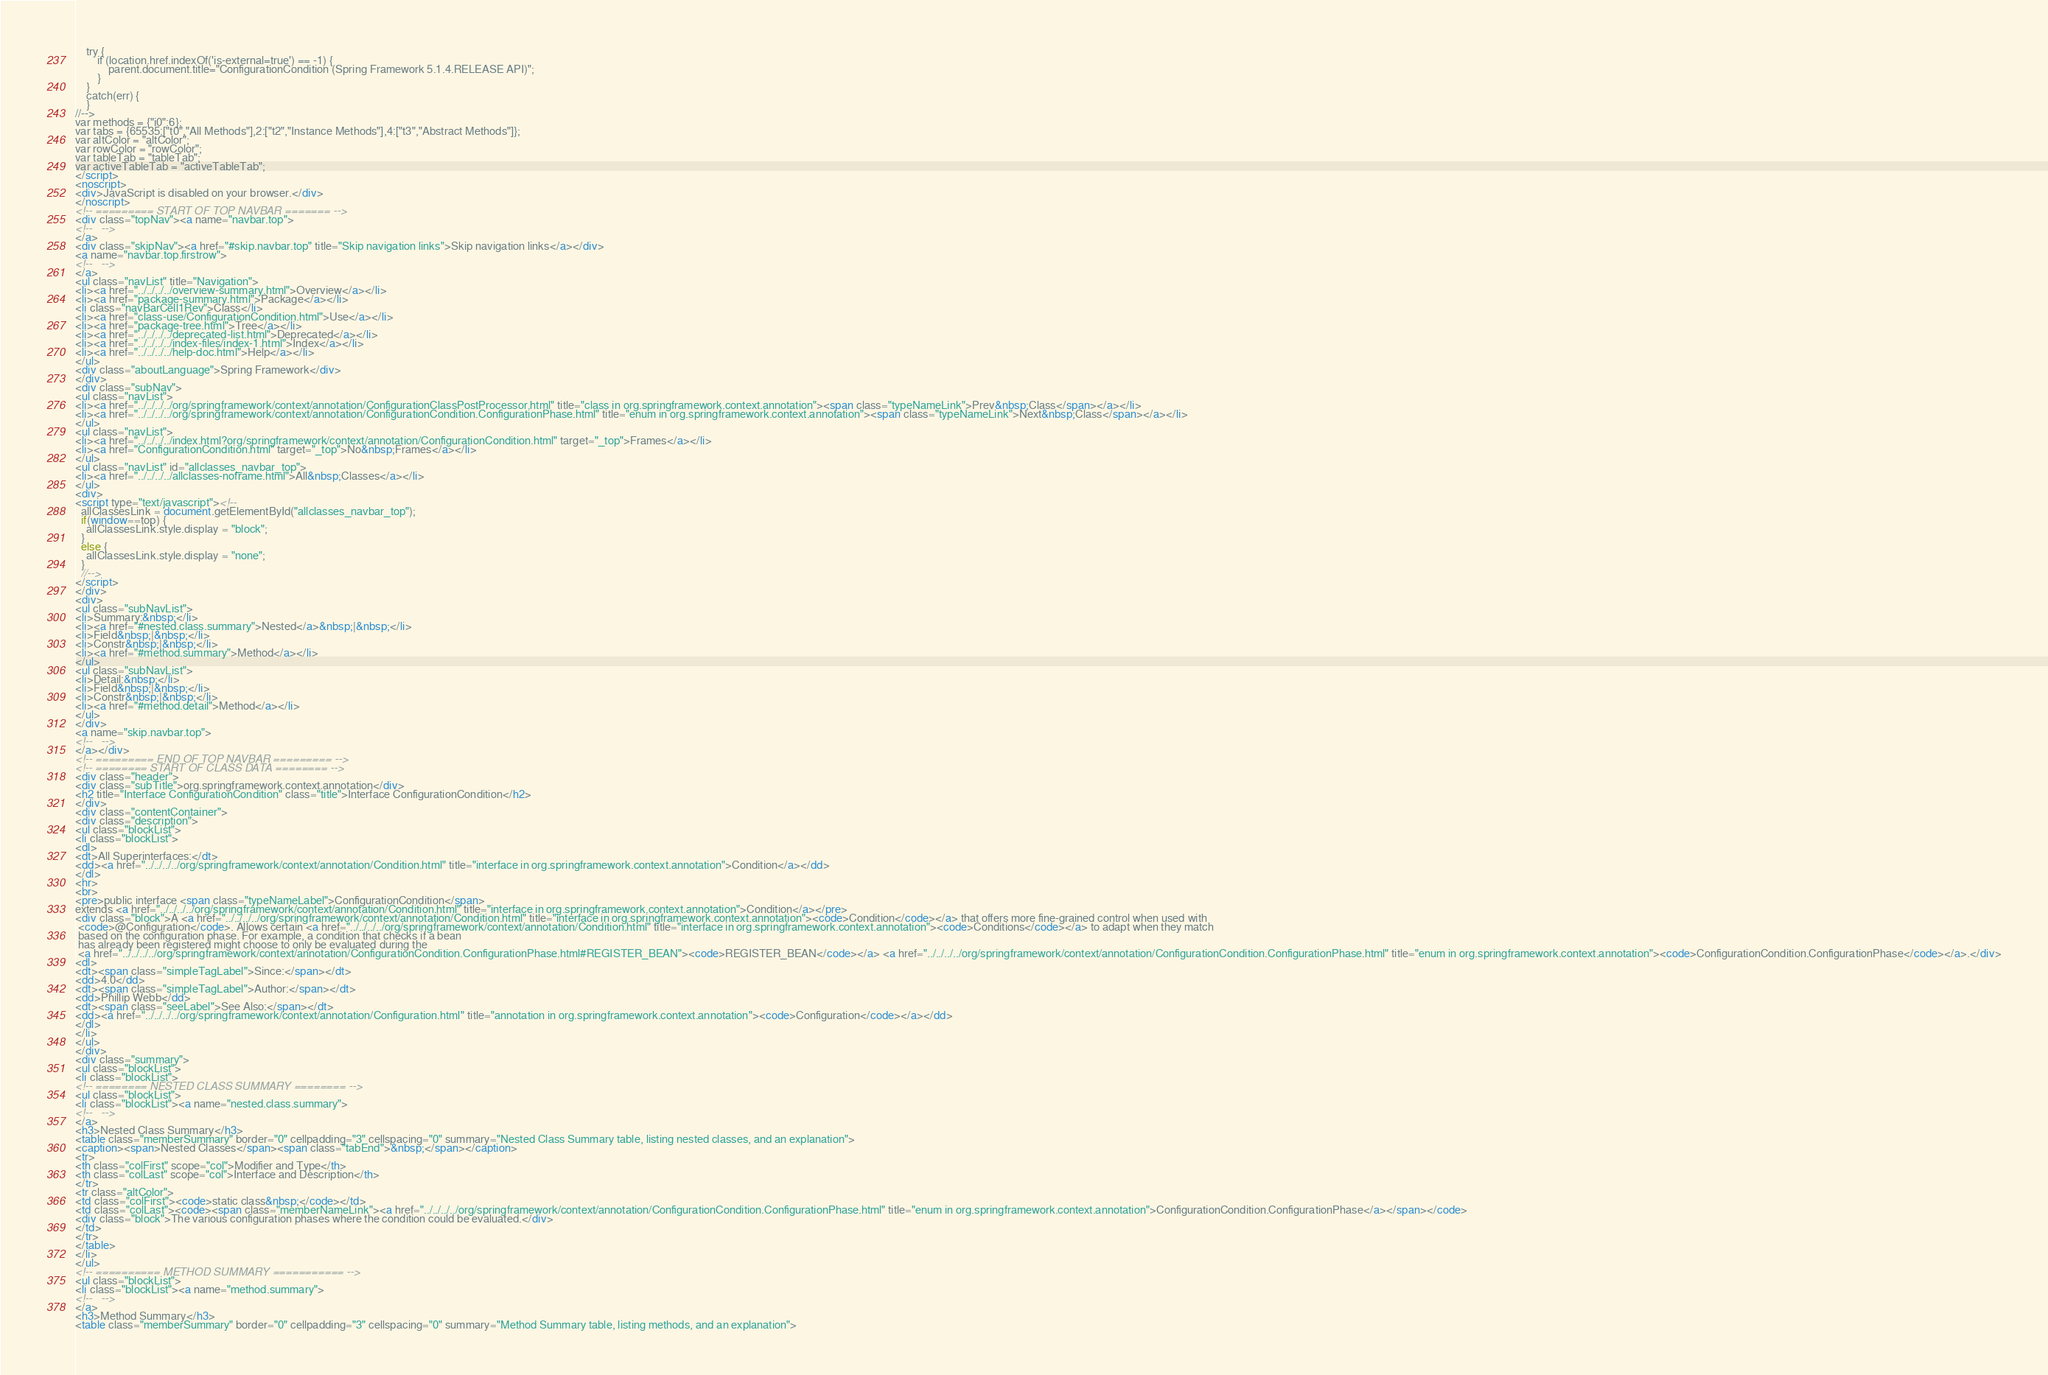Convert code to text. <code><loc_0><loc_0><loc_500><loc_500><_HTML_>    try {
        if (location.href.indexOf('is-external=true') == -1) {
            parent.document.title="ConfigurationCondition (Spring Framework 5.1.4.RELEASE API)";
        }
    }
    catch(err) {
    }
//-->
var methods = {"i0":6};
var tabs = {65535:["t0","All Methods"],2:["t2","Instance Methods"],4:["t3","Abstract Methods"]};
var altColor = "altColor";
var rowColor = "rowColor";
var tableTab = "tableTab";
var activeTableTab = "activeTableTab";
</script>
<noscript>
<div>JavaScript is disabled on your browser.</div>
</noscript>
<!-- ========= START OF TOP NAVBAR ======= -->
<div class="topNav"><a name="navbar.top">
<!--   -->
</a>
<div class="skipNav"><a href="#skip.navbar.top" title="Skip navigation links">Skip navigation links</a></div>
<a name="navbar.top.firstrow">
<!--   -->
</a>
<ul class="navList" title="Navigation">
<li><a href="../../../../overview-summary.html">Overview</a></li>
<li><a href="package-summary.html">Package</a></li>
<li class="navBarCell1Rev">Class</li>
<li><a href="class-use/ConfigurationCondition.html">Use</a></li>
<li><a href="package-tree.html">Tree</a></li>
<li><a href="../../../../deprecated-list.html">Deprecated</a></li>
<li><a href="../../../../index-files/index-1.html">Index</a></li>
<li><a href="../../../../help-doc.html">Help</a></li>
</ul>
<div class="aboutLanguage">Spring Framework</div>
</div>
<div class="subNav">
<ul class="navList">
<li><a href="../../../../org/springframework/context/annotation/ConfigurationClassPostProcessor.html" title="class in org.springframework.context.annotation"><span class="typeNameLink">Prev&nbsp;Class</span></a></li>
<li><a href="../../../../org/springframework/context/annotation/ConfigurationCondition.ConfigurationPhase.html" title="enum in org.springframework.context.annotation"><span class="typeNameLink">Next&nbsp;Class</span></a></li>
</ul>
<ul class="navList">
<li><a href="../../../../index.html?org/springframework/context/annotation/ConfigurationCondition.html" target="_top">Frames</a></li>
<li><a href="ConfigurationCondition.html" target="_top">No&nbsp;Frames</a></li>
</ul>
<ul class="navList" id="allclasses_navbar_top">
<li><a href="../../../../allclasses-noframe.html">All&nbsp;Classes</a></li>
</ul>
<div>
<script type="text/javascript"><!--
  allClassesLink = document.getElementById("allclasses_navbar_top");
  if(window==top) {
    allClassesLink.style.display = "block";
  }
  else {
    allClassesLink.style.display = "none";
  }
  //-->
</script>
</div>
<div>
<ul class="subNavList">
<li>Summary:&nbsp;</li>
<li><a href="#nested.class.summary">Nested</a>&nbsp;|&nbsp;</li>
<li>Field&nbsp;|&nbsp;</li>
<li>Constr&nbsp;|&nbsp;</li>
<li><a href="#method.summary">Method</a></li>
</ul>
<ul class="subNavList">
<li>Detail:&nbsp;</li>
<li>Field&nbsp;|&nbsp;</li>
<li>Constr&nbsp;|&nbsp;</li>
<li><a href="#method.detail">Method</a></li>
</ul>
</div>
<a name="skip.navbar.top">
<!--   -->
</a></div>
<!-- ========= END OF TOP NAVBAR ========= -->
<!-- ======== START OF CLASS DATA ======== -->
<div class="header">
<div class="subTitle">org.springframework.context.annotation</div>
<h2 title="Interface ConfigurationCondition" class="title">Interface ConfigurationCondition</h2>
</div>
<div class="contentContainer">
<div class="description">
<ul class="blockList">
<li class="blockList">
<dl>
<dt>All Superinterfaces:</dt>
<dd><a href="../../../../org/springframework/context/annotation/Condition.html" title="interface in org.springframework.context.annotation">Condition</a></dd>
</dl>
<hr>
<br>
<pre>public interface <span class="typeNameLabel">ConfigurationCondition</span>
extends <a href="../../../../org/springframework/context/annotation/Condition.html" title="interface in org.springframework.context.annotation">Condition</a></pre>
<div class="block">A <a href="../../../../org/springframework/context/annotation/Condition.html" title="interface in org.springframework.context.annotation"><code>Condition</code></a> that offers more fine-grained control when used with
 <code>@Configuration</code>. Allows certain <a href="../../../../org/springframework/context/annotation/Condition.html" title="interface in org.springframework.context.annotation"><code>Conditions</code></a> to adapt when they match
 based on the configuration phase. For example, a condition that checks if a bean
 has already been registered might choose to only be evaluated during the
 <a href="../../../../org/springframework/context/annotation/ConfigurationCondition.ConfigurationPhase.html#REGISTER_BEAN"><code>REGISTER_BEAN</code></a> <a href="../../../../org/springframework/context/annotation/ConfigurationCondition.ConfigurationPhase.html" title="enum in org.springframework.context.annotation"><code>ConfigurationCondition.ConfigurationPhase</code></a>.</div>
<dl>
<dt><span class="simpleTagLabel">Since:</span></dt>
<dd>4.0</dd>
<dt><span class="simpleTagLabel">Author:</span></dt>
<dd>Phillip Webb</dd>
<dt><span class="seeLabel">See Also:</span></dt>
<dd><a href="../../../../org/springframework/context/annotation/Configuration.html" title="annotation in org.springframework.context.annotation"><code>Configuration</code></a></dd>
</dl>
</li>
</ul>
</div>
<div class="summary">
<ul class="blockList">
<li class="blockList">
<!-- ======== NESTED CLASS SUMMARY ======== -->
<ul class="blockList">
<li class="blockList"><a name="nested.class.summary">
<!--   -->
</a>
<h3>Nested Class Summary</h3>
<table class="memberSummary" border="0" cellpadding="3" cellspacing="0" summary="Nested Class Summary table, listing nested classes, and an explanation">
<caption><span>Nested Classes</span><span class="tabEnd">&nbsp;</span></caption>
<tr>
<th class="colFirst" scope="col">Modifier and Type</th>
<th class="colLast" scope="col">Interface and Description</th>
</tr>
<tr class="altColor">
<td class="colFirst"><code>static class&nbsp;</code></td>
<td class="colLast"><code><span class="memberNameLink"><a href="../../../../org/springframework/context/annotation/ConfigurationCondition.ConfigurationPhase.html" title="enum in org.springframework.context.annotation">ConfigurationCondition.ConfigurationPhase</a></span></code>
<div class="block">The various configuration phases where the condition could be evaluated.</div>
</td>
</tr>
</table>
</li>
</ul>
<!-- ========== METHOD SUMMARY =========== -->
<ul class="blockList">
<li class="blockList"><a name="method.summary">
<!--   -->
</a>
<h3>Method Summary</h3>
<table class="memberSummary" border="0" cellpadding="3" cellspacing="0" summary="Method Summary table, listing methods, and an explanation"></code> 